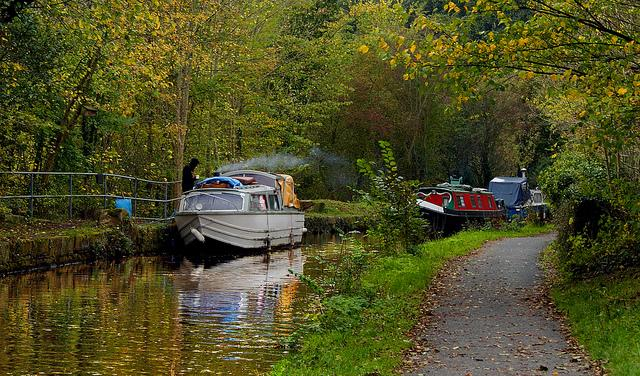What type byway is shown here?

Choices:
A) freeway
B) raceway
C) nature path
D) railway nature path 